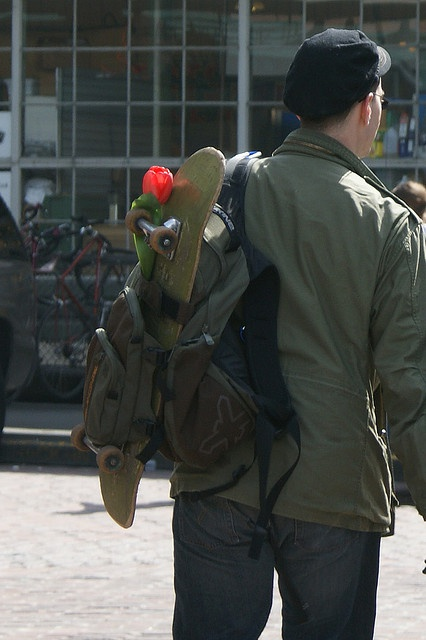Describe the objects in this image and their specific colors. I can see people in black, gray, and darkgreen tones, backpack in black, darkgreen, and gray tones, skateboard in black, darkgreen, and gray tones, bicycle in black and purple tones, and bicycle in black and purple tones in this image. 